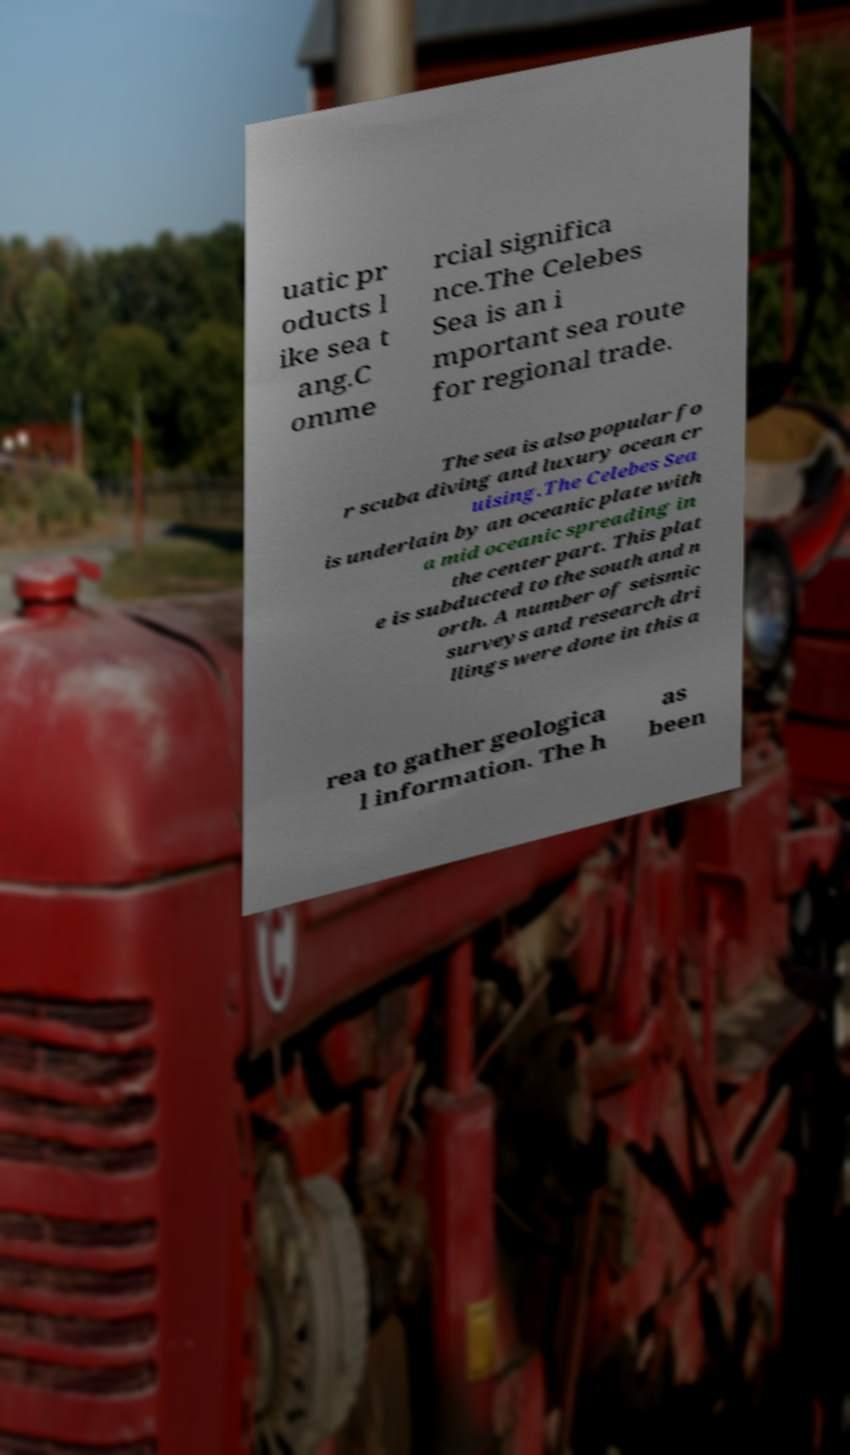Can you accurately transcribe the text from the provided image for me? uatic pr oducts l ike sea t ang.C omme rcial significa nce.The Celebes Sea is an i mportant sea route for regional trade. The sea is also popular fo r scuba diving and luxury ocean cr uising.The Celebes Sea is underlain by an oceanic plate with a mid oceanic spreading in the center part. This plat e is subducted to the south and n orth. A number of seismic surveys and research dri llings were done in this a rea to gather geologica l information. The h as been 